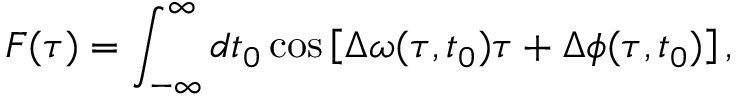Convert formula to latex. <formula><loc_0><loc_0><loc_500><loc_500>F ( \tau ) = \int _ { - \infty } ^ { \infty } d t _ { 0 } \cos \left [ \Delta \omega ( \tau , t _ { 0 } ) \tau + \Delta \phi ( \tau , t _ { 0 } ) \right ] ,</formula> 